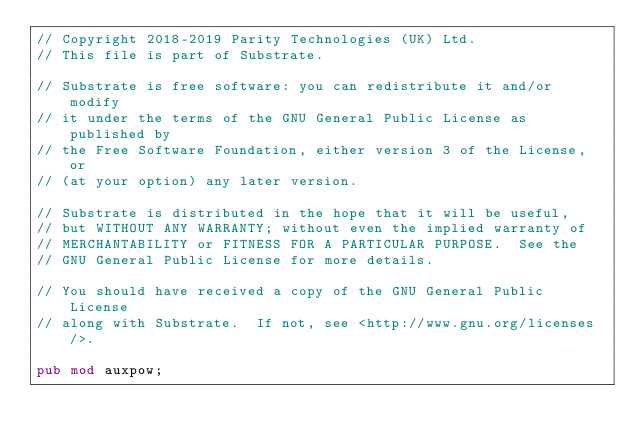Convert code to text. <code><loc_0><loc_0><loc_500><loc_500><_Rust_>// Copyright 2018-2019 Parity Technologies (UK) Ltd.
// This file is part of Substrate.

// Substrate is free software: you can redistribute it and/or modify
// it under the terms of the GNU General Public License as published by
// the Free Software Foundation, either version 3 of the License, or
// (at your option) any later version.

// Substrate is distributed in the hope that it will be useful,
// but WITHOUT ANY WARRANTY; without even the implied warranty of
// MERCHANTABILITY or FITNESS FOR A PARTICULAR PURPOSE.  See the
// GNU General Public License for more details.

// You should have received a copy of the GNU General Public License
// along with Substrate.  If not, see <http://www.gnu.org/licenses/>.

pub mod auxpow;
</code> 